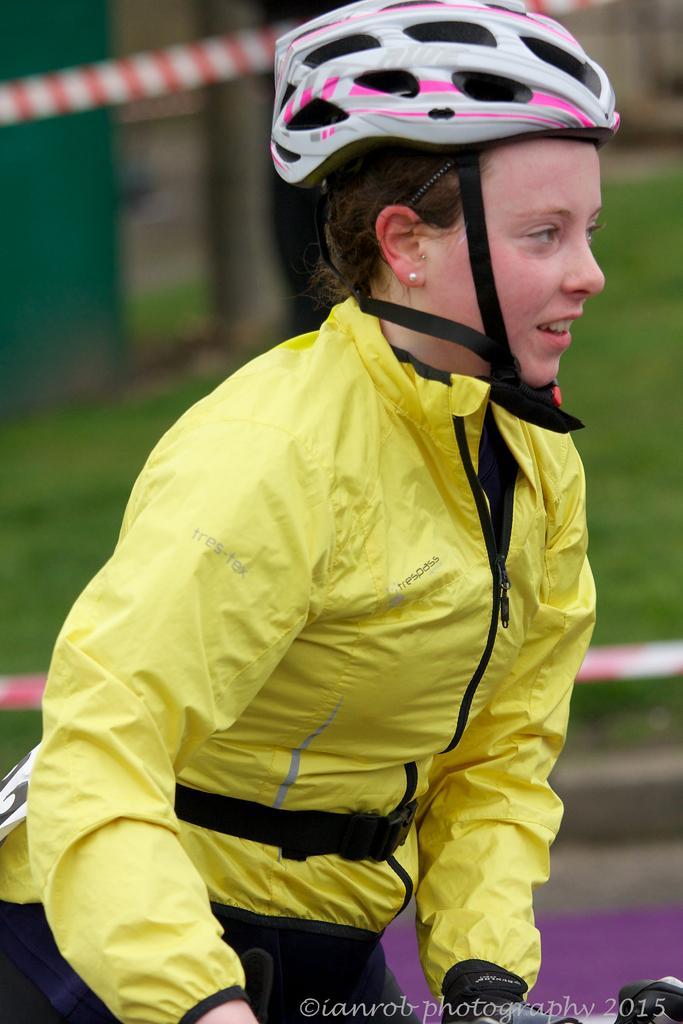In one or two sentences, can you explain what this image depicts? In this image we can see a woman wearing yellow color jacket and helmet. The background of the image is blurred, where we can see grass and ropes here. 